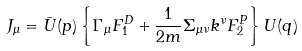<formula> <loc_0><loc_0><loc_500><loc_500>J _ { \mu } = \bar { U } ( p ) \left \{ \Gamma _ { \mu } F ^ { D } _ { 1 } + \frac { 1 } { 2 m } \Sigma _ { \mu \nu } k ^ { \nu } F ^ { P } _ { 2 } \right \} U ( q )</formula> 